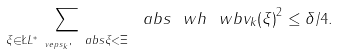Convert formula to latex. <formula><loc_0><loc_0><loc_500><loc_500>\sum _ { \xi \in \L L ^ { \ast } _ { \ v e p s _ { k } } , \ a b s { \xi } < \Xi } \ a b s { \ w h { \ w b { v } _ { k } } ( \xi ) } ^ { 2 } \leq \delta / 4 .</formula> 